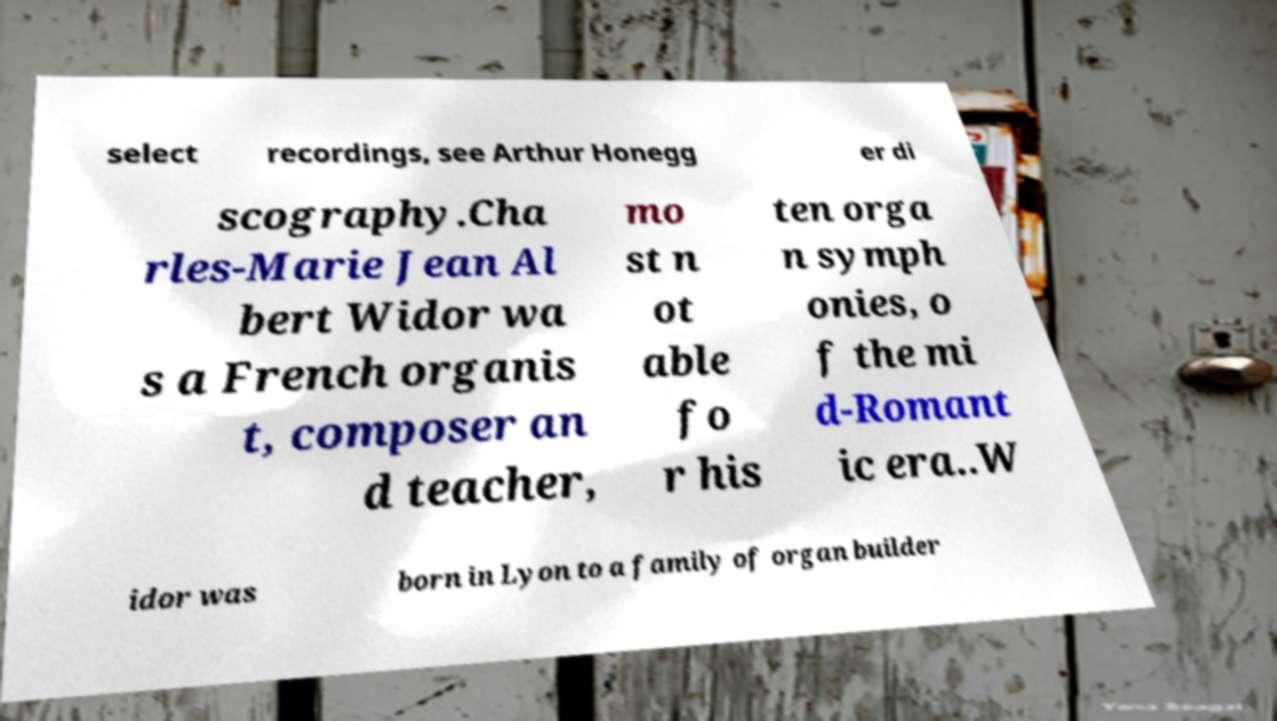Can you accurately transcribe the text from the provided image for me? select recordings, see Arthur Honegg er di scography.Cha rles-Marie Jean Al bert Widor wa s a French organis t, composer an d teacher, mo st n ot able fo r his ten orga n symph onies, o f the mi d-Romant ic era..W idor was born in Lyon to a family of organ builder 